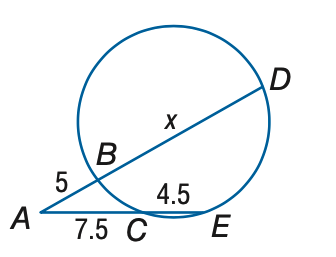Question: Find x.
Choices:
A. 12
B. 13
C. 14
D. 15
Answer with the letter. Answer: B 